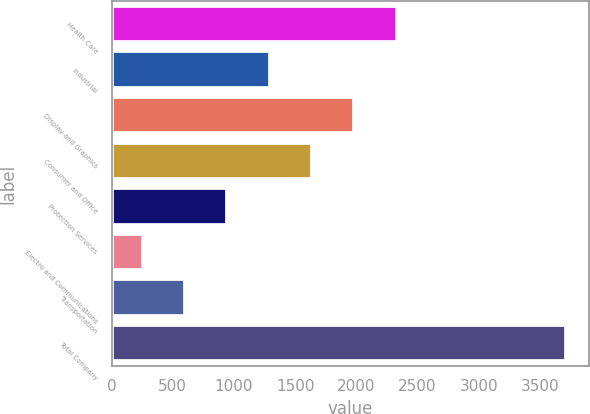Convert chart. <chart><loc_0><loc_0><loc_500><loc_500><bar_chart><fcel>Health Care<fcel>Industrial<fcel>Display and Graphics<fcel>Consumer and Office<fcel>Protection Services<fcel>Electro and Communications<fcel>Transportation<fcel>Total Company<nl><fcel>2329.8<fcel>1292.4<fcel>1984<fcel>1638.2<fcel>946.6<fcel>255<fcel>600.8<fcel>3713<nl></chart> 